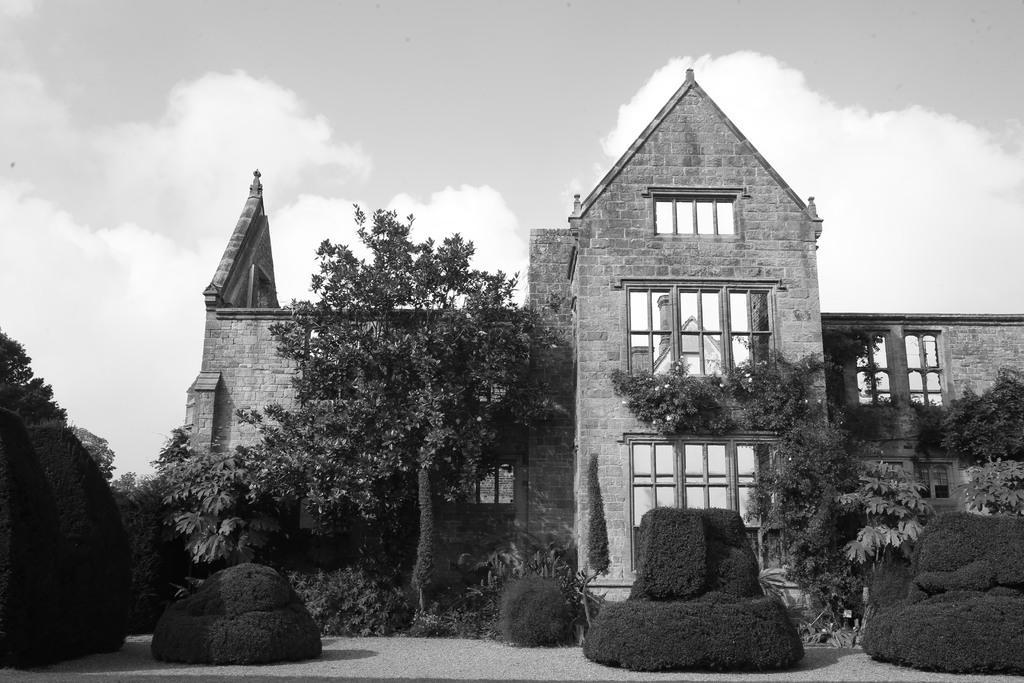Could you give a brief overview of what you see in this image? In this picture we can see a building with windows, trees, plants and in the background we can see the sky with clouds. 